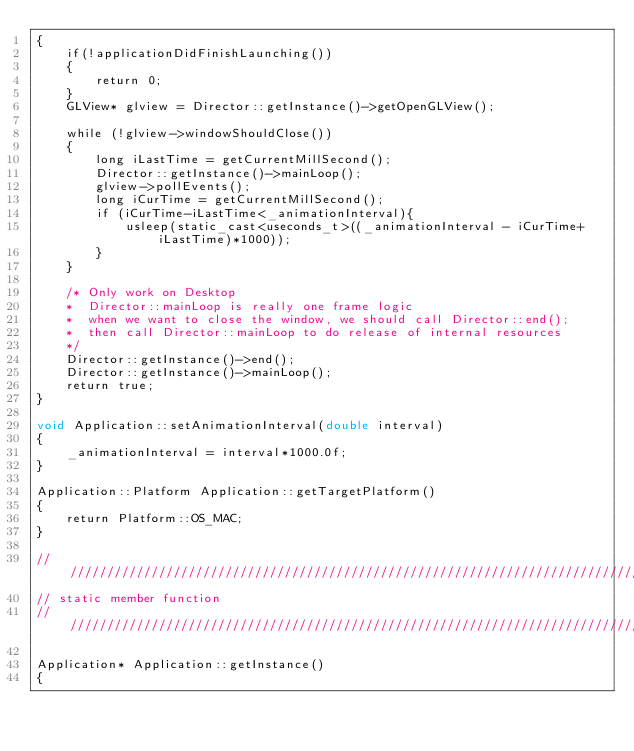Convert code to text. <code><loc_0><loc_0><loc_500><loc_500><_ObjectiveC_>{
    if(!applicationDidFinishLaunching())
    {
        return 0;
    }
    GLView* glview = Director::getInstance()->getOpenGLView();
    
    while (!glview->windowShouldClose())
    {
        long iLastTime = getCurrentMillSecond();
        Director::getInstance()->mainLoop();
        glview->pollEvents();
        long iCurTime = getCurrentMillSecond();
        if (iCurTime-iLastTime<_animationInterval){
            usleep(static_cast<useconds_t>((_animationInterval - iCurTime+iLastTime)*1000));
        }
    }

    /* Only work on Desktop
    *  Director::mainLoop is really one frame logic
    *  when we want to close the window, we should call Director::end();
    *  then call Director::mainLoop to do release of internal resources
    */
    Director::getInstance()->end();
    Director::getInstance()->mainLoop();
    return true;
}

void Application::setAnimationInterval(double interval)
{
    _animationInterval = interval*1000.0f;
}

Application::Platform Application::getTargetPlatform()
{
    return Platform::OS_MAC;
}

/////////////////////////////////////////////////////////////////////////////////////////////////
// static member function
//////////////////////////////////////////////////////////////////////////////////////////////////

Application* Application::getInstance()
{</code> 